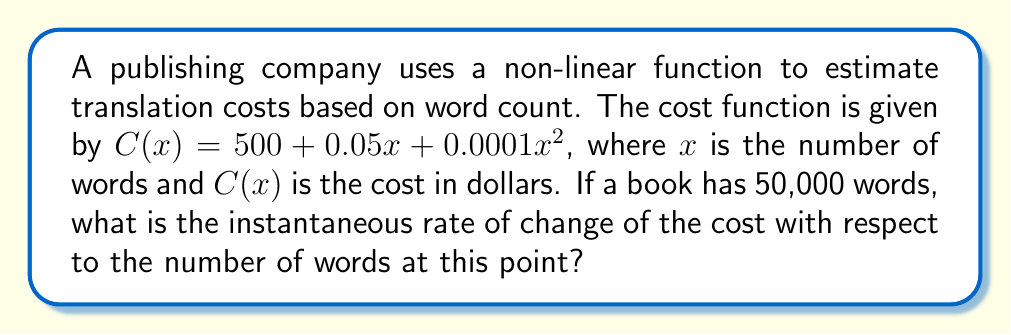Help me with this question. To find the instantaneous rate of change of the cost with respect to the number of words, we need to find the derivative of the cost function $C(x)$ and evaluate it at $x = 50,000$.

1) The cost function is $C(x) = 500 + 0.05x + 0.0001x^2$

2) To find the derivative, we use the power rule and constant rule:
   $$C'(x) = 0 + 0.05 + 2(0.0001)x$$
   $$C'(x) = 0.05 + 0.0002x$$

3) Now, we evaluate $C'(x)$ at $x = 50,000$:
   $$C'(50,000) = 0.05 + 0.0002(50,000)$$
   $$C'(50,000) = 0.05 + 10$$
   $$C'(50,000) = 10.05$$

4) This means that at 50,000 words, the cost is increasing at a rate of $10.05 per word.
Answer: $10.05 per word 